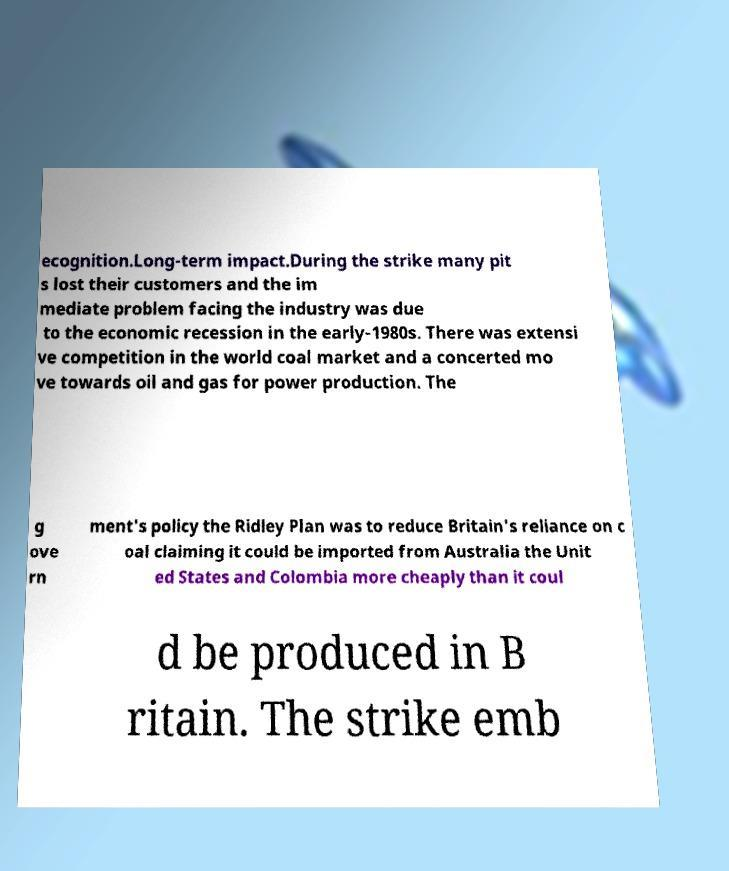Can you accurately transcribe the text from the provided image for me? ecognition.Long-term impact.During the strike many pit s lost their customers and the im mediate problem facing the industry was due to the economic recession in the early-1980s. There was extensi ve competition in the world coal market and a concerted mo ve towards oil and gas for power production. The g ove rn ment's policy the Ridley Plan was to reduce Britain's reliance on c oal claiming it could be imported from Australia the Unit ed States and Colombia more cheaply than it coul d be produced in B ritain. The strike emb 